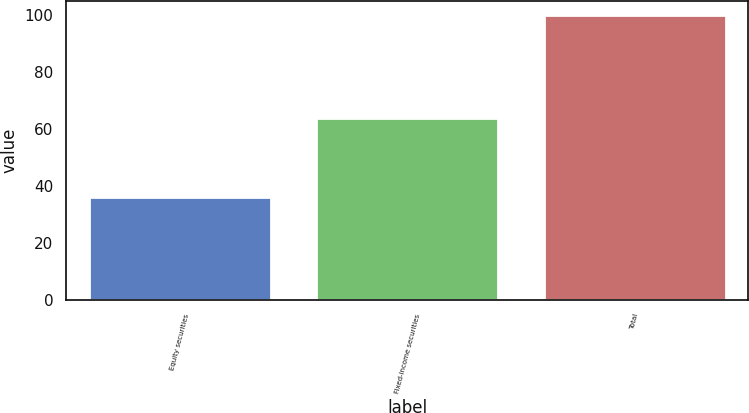<chart> <loc_0><loc_0><loc_500><loc_500><bar_chart><fcel>Equity securities<fcel>Fixed-income securities<fcel>Total<nl><fcel>36<fcel>64<fcel>100<nl></chart> 